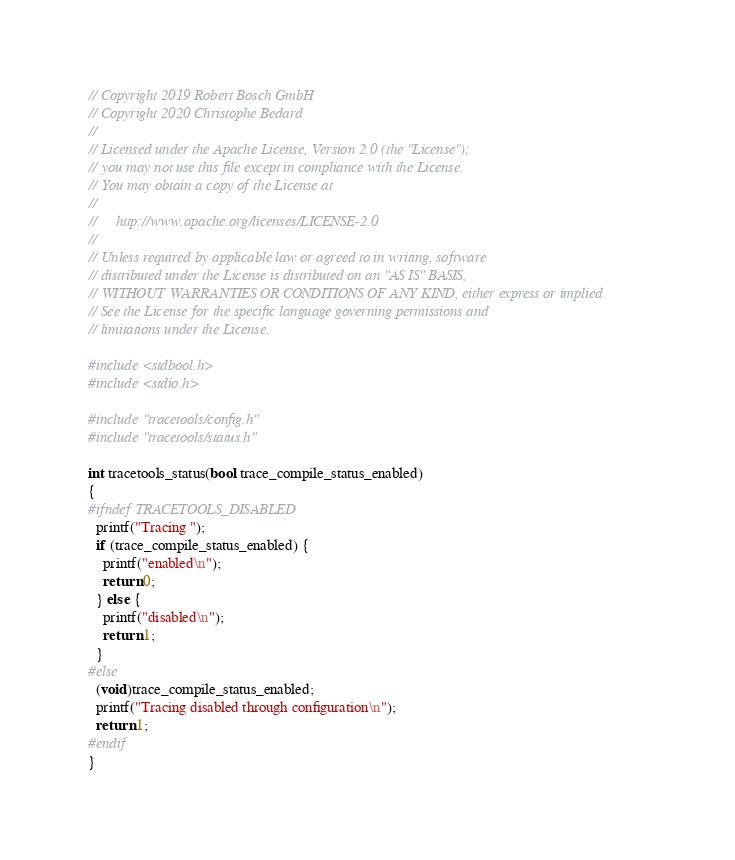Convert code to text. <code><loc_0><loc_0><loc_500><loc_500><_C_>// Copyright 2019 Robert Bosch GmbH
// Copyright 2020 Christophe Bedard
//
// Licensed under the Apache License, Version 2.0 (the "License");
// you may not use this file except in compliance with the License.
// You may obtain a copy of the License at
//
//     http://www.apache.org/licenses/LICENSE-2.0
//
// Unless required by applicable law or agreed to in writing, software
// distributed under the License is distributed on an "AS IS" BASIS,
// WITHOUT WARRANTIES OR CONDITIONS OF ANY KIND, either express or implied.
// See the License for the specific language governing permissions and
// limitations under the License.

#include <stdbool.h>
#include <stdio.h>

#include "tracetools/config.h"
#include "tracetools/status.h"

int tracetools_status(bool trace_compile_status_enabled)
{
#ifndef TRACETOOLS_DISABLED
  printf("Tracing ");
  if (trace_compile_status_enabled) {
    printf("enabled\n");
    return 0;
  } else {
    printf("disabled\n");
    return 1;
  }
#else
  (void)trace_compile_status_enabled;
  printf("Tracing disabled through configuration\n");
  return 1;
#endif
}
</code> 